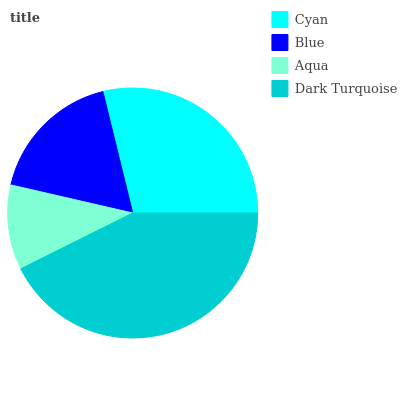Is Aqua the minimum?
Answer yes or no. Yes. Is Dark Turquoise the maximum?
Answer yes or no. Yes. Is Blue the minimum?
Answer yes or no. No. Is Blue the maximum?
Answer yes or no. No. Is Cyan greater than Blue?
Answer yes or no. Yes. Is Blue less than Cyan?
Answer yes or no. Yes. Is Blue greater than Cyan?
Answer yes or no. No. Is Cyan less than Blue?
Answer yes or no. No. Is Cyan the high median?
Answer yes or no. Yes. Is Blue the low median?
Answer yes or no. Yes. Is Dark Turquoise the high median?
Answer yes or no. No. Is Cyan the low median?
Answer yes or no. No. 